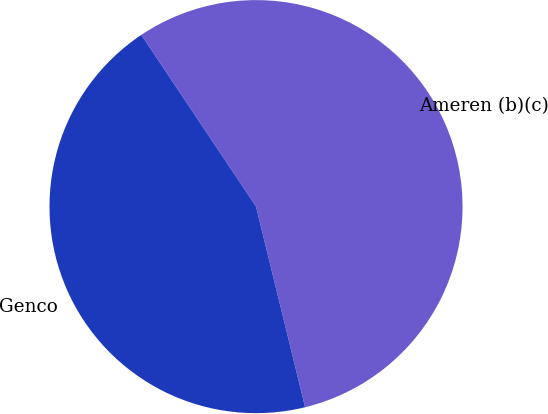<chart> <loc_0><loc_0><loc_500><loc_500><pie_chart><fcel>Ameren (b)(c)<fcel>Genco<nl><fcel>55.56%<fcel>44.44%<nl></chart> 